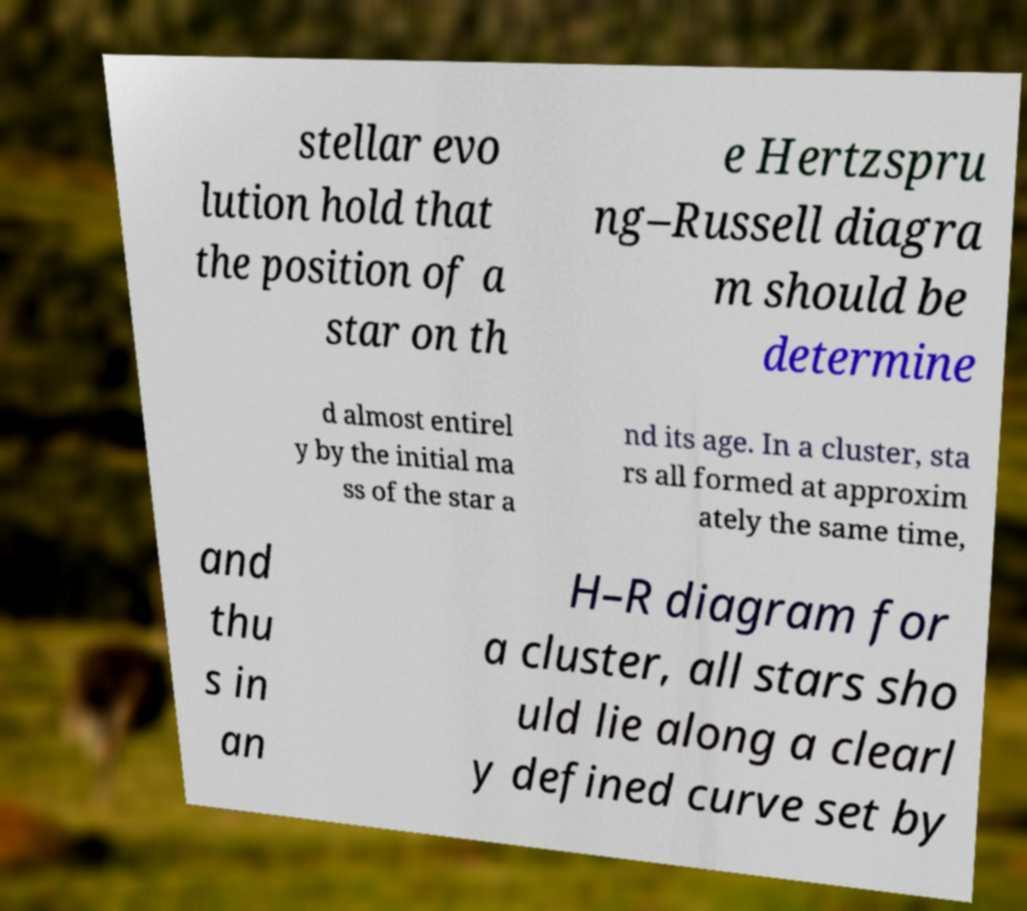For documentation purposes, I need the text within this image transcribed. Could you provide that? stellar evo lution hold that the position of a star on th e Hertzspru ng–Russell diagra m should be determine d almost entirel y by the initial ma ss of the star a nd its age. In a cluster, sta rs all formed at approxim ately the same time, and thu s in an H–R diagram for a cluster, all stars sho uld lie along a clearl y defined curve set by 